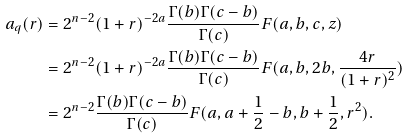<formula> <loc_0><loc_0><loc_500><loc_500>a _ { q } ( r ) & = 2 ^ { n - 2 } ( 1 + r ) ^ { - 2 a } \frac { \Gamma ( b ) \Gamma ( c - b ) } { \Gamma ( c ) } { F } ( a , b , c , z ) \\ & = 2 ^ { n - 2 } ( 1 + r ) ^ { - 2 a } \frac { \Gamma ( b ) \Gamma ( c - b ) } { \Gamma ( c ) } { F } ( a , b , 2 b , \frac { 4 r } { ( 1 + r ) ^ { 2 } } ) \\ & = 2 ^ { n - 2 } \frac { \Gamma ( b ) \Gamma ( c - b ) } { \Gamma ( c ) } { F } ( a , a + \frac { 1 } { 2 } - b , b + \frac { 1 } { 2 } , r ^ { 2 } ) .</formula> 